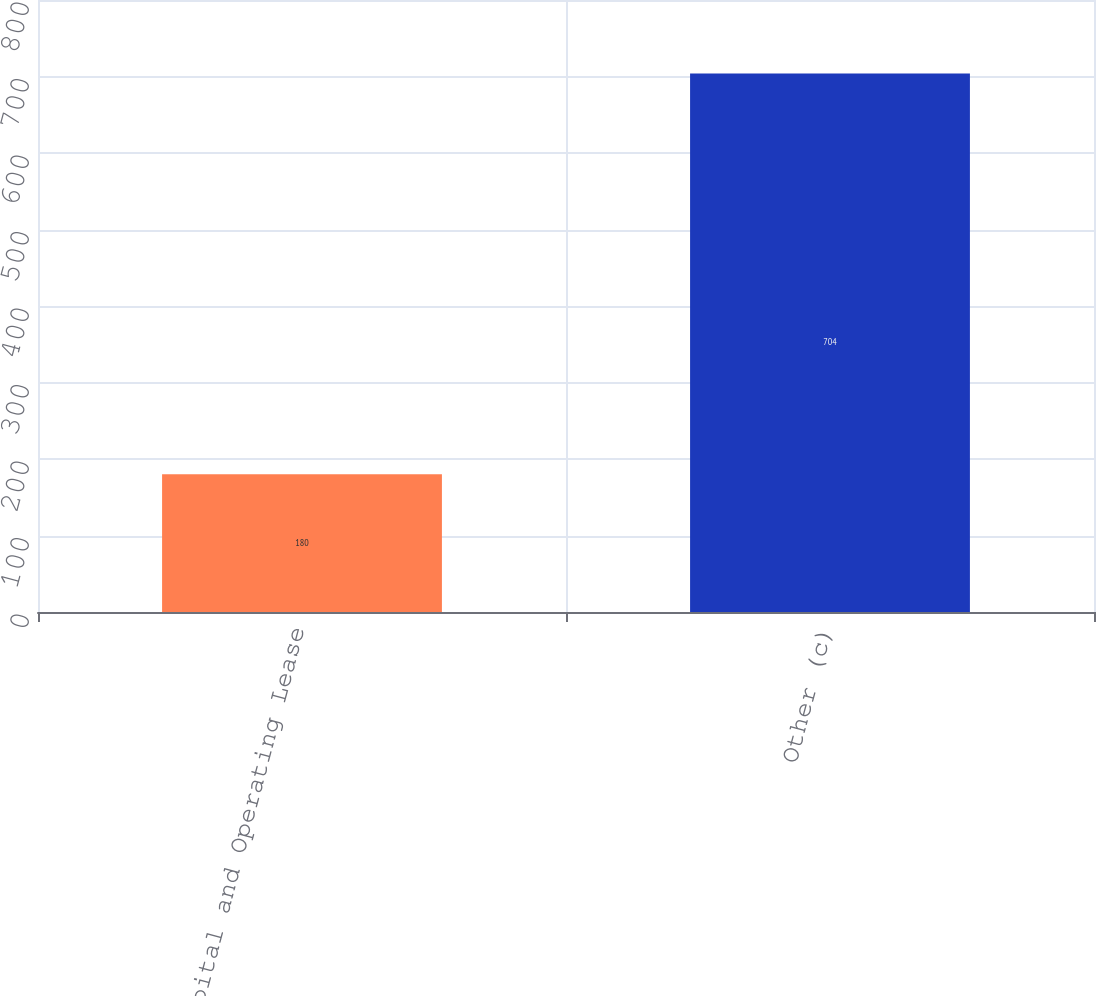Convert chart to OTSL. <chart><loc_0><loc_0><loc_500><loc_500><bar_chart><fcel>Capital and Operating Lease<fcel>Other (c)<nl><fcel>180<fcel>704<nl></chart> 